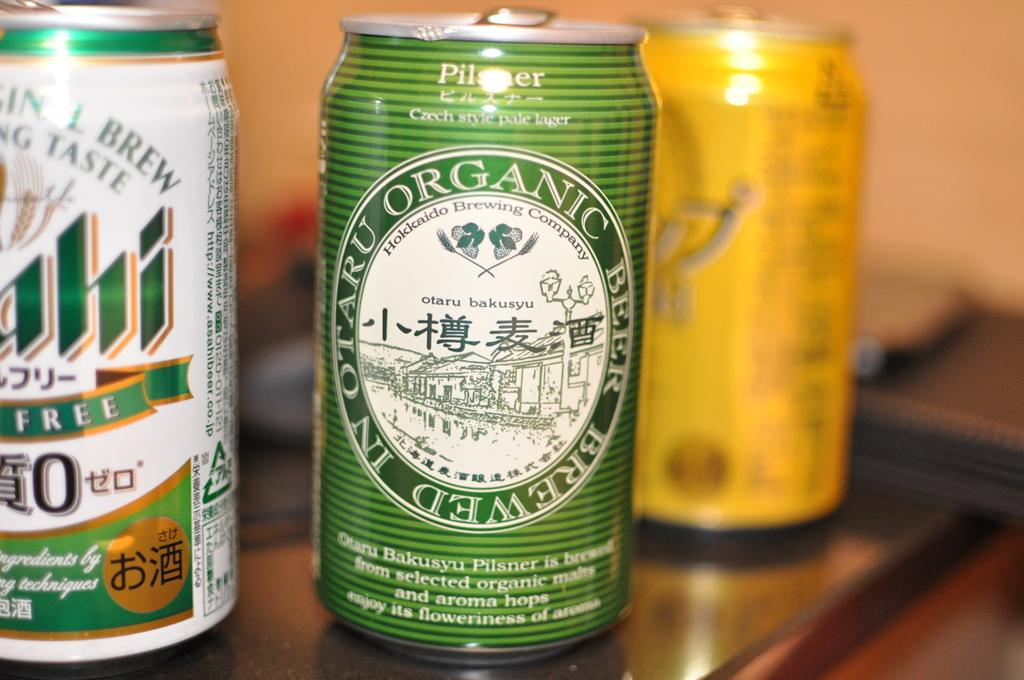<image>
Present a compact description of the photo's key features. A can of In Otaru Organic Beer with a pictue of a town as its logo 